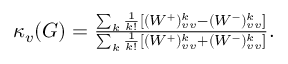<formula> <loc_0><loc_0><loc_500><loc_500>\begin{array} { r } { \kappa _ { v } ( G ) = \frac { \sum _ { k } \frac { 1 } { k ! } [ ( W ^ { + } ) _ { v v } ^ { k } - ( W ^ { - } ) _ { v v } ^ { k } ] } { \sum _ { k } \frac { 1 } { k ! } [ ( W ^ { + } ) _ { v v } ^ { k } + ( W ^ { - } ) _ { v v } ^ { k } ] } . } \end{array}</formula> 